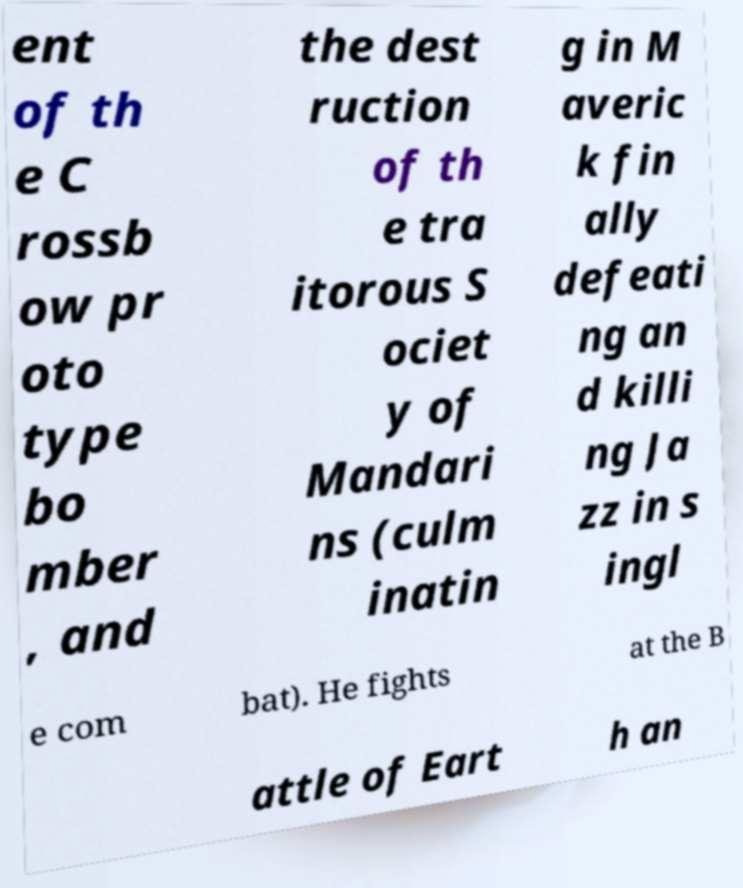Can you read and provide the text displayed in the image?This photo seems to have some interesting text. Can you extract and type it out for me? ent of th e C rossb ow pr oto type bo mber , and the dest ruction of th e tra itorous S ociet y of Mandari ns (culm inatin g in M averic k fin ally defeati ng an d killi ng Ja zz in s ingl e com bat). He fights at the B attle of Eart h an 